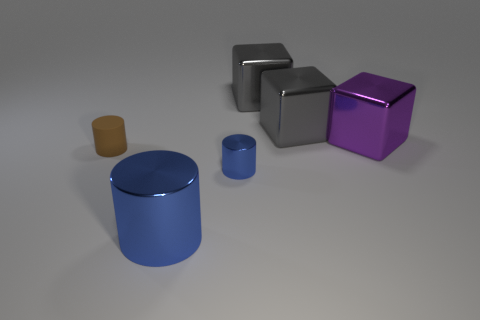Subtract all big purple metallic cubes. How many cubes are left? 2 Add 1 gray metallic spheres. How many objects exist? 7 Subtract all purple blocks. How many blocks are left? 2 Subtract 1 blocks. How many blocks are left? 2 Subtract all green cylinders. How many purple blocks are left? 1 Add 6 large shiny blocks. How many large shiny blocks are left? 9 Add 6 green metal cylinders. How many green metal cylinders exist? 6 Subtract 0 green spheres. How many objects are left? 6 Subtract all brown cubes. Subtract all brown balls. How many cubes are left? 3 Subtract all purple metallic objects. Subtract all large gray blocks. How many objects are left? 3 